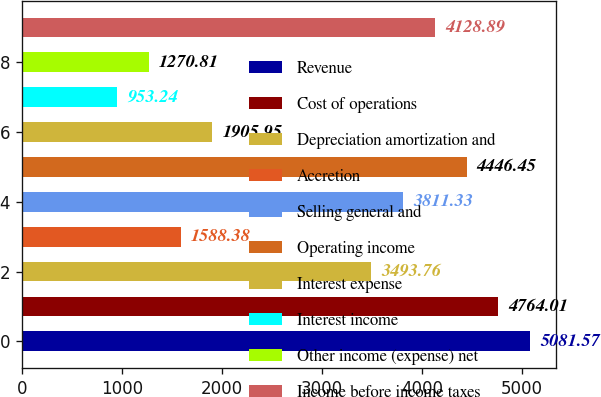Convert chart to OTSL. <chart><loc_0><loc_0><loc_500><loc_500><bar_chart><fcel>Revenue<fcel>Cost of operations<fcel>Depreciation amortization and<fcel>Accretion<fcel>Selling general and<fcel>Operating income<fcel>Interest expense<fcel>Interest income<fcel>Other income (expense) net<fcel>Income before income taxes<nl><fcel>5081.57<fcel>4764.01<fcel>3493.76<fcel>1588.38<fcel>3811.33<fcel>4446.45<fcel>1905.95<fcel>953.24<fcel>1270.81<fcel>4128.89<nl></chart> 